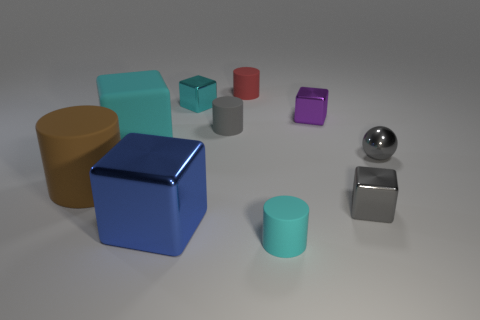Subtract all gray blocks. How many blocks are left? 4 Subtract 2 cubes. How many cubes are left? 3 Subtract all tiny cyan metallic blocks. How many blocks are left? 4 Subtract all gray blocks. Subtract all red cylinders. How many blocks are left? 4 Subtract all cylinders. How many objects are left? 6 Add 7 big brown cylinders. How many big brown cylinders are left? 8 Add 2 large gray cubes. How many large gray cubes exist? 2 Subtract 1 cyan cylinders. How many objects are left? 9 Subtract all red balls. Subtract all gray blocks. How many objects are left? 9 